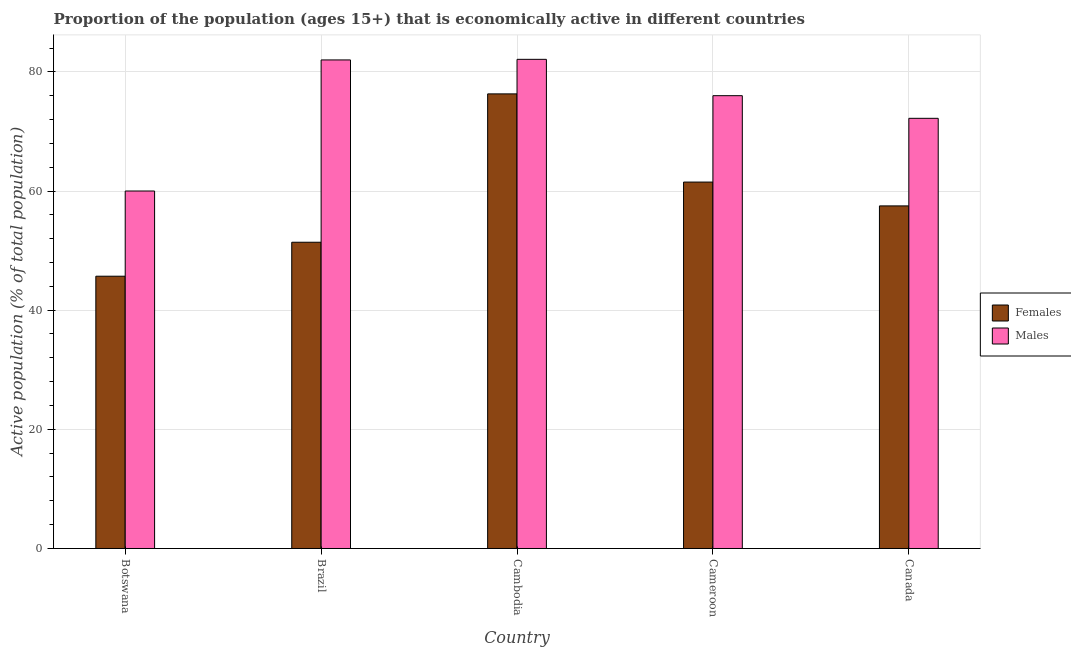How many groups of bars are there?
Give a very brief answer. 5. Are the number of bars per tick equal to the number of legend labels?
Your response must be concise. Yes. Are the number of bars on each tick of the X-axis equal?
Ensure brevity in your answer.  Yes. How many bars are there on the 4th tick from the left?
Provide a succinct answer. 2. How many bars are there on the 1st tick from the right?
Offer a very short reply. 2. What is the label of the 3rd group of bars from the left?
Your answer should be compact. Cambodia. What is the percentage of economically active female population in Cambodia?
Provide a short and direct response. 76.3. Across all countries, what is the maximum percentage of economically active male population?
Offer a very short reply. 82.1. Across all countries, what is the minimum percentage of economically active female population?
Offer a terse response. 45.7. In which country was the percentage of economically active female population maximum?
Provide a succinct answer. Cambodia. In which country was the percentage of economically active female population minimum?
Provide a short and direct response. Botswana. What is the total percentage of economically active female population in the graph?
Keep it short and to the point. 292.4. What is the difference between the percentage of economically active male population in Botswana and that in Canada?
Offer a terse response. -12.2. What is the difference between the percentage of economically active male population in Cambodia and the percentage of economically active female population in Brazil?
Provide a short and direct response. 30.7. What is the average percentage of economically active female population per country?
Offer a terse response. 58.48. What is the difference between the percentage of economically active male population and percentage of economically active female population in Brazil?
Keep it short and to the point. 30.6. In how many countries, is the percentage of economically active female population greater than 60 %?
Offer a terse response. 2. What is the ratio of the percentage of economically active male population in Brazil to that in Canada?
Provide a short and direct response. 1.14. What is the difference between the highest and the second highest percentage of economically active female population?
Your response must be concise. 14.8. What is the difference between the highest and the lowest percentage of economically active female population?
Provide a succinct answer. 30.6. In how many countries, is the percentage of economically active female population greater than the average percentage of economically active female population taken over all countries?
Make the answer very short. 2. Is the sum of the percentage of economically active male population in Botswana and Cambodia greater than the maximum percentage of economically active female population across all countries?
Give a very brief answer. Yes. What does the 2nd bar from the left in Brazil represents?
Your answer should be compact. Males. What does the 2nd bar from the right in Cambodia represents?
Your answer should be compact. Females. How many countries are there in the graph?
Offer a very short reply. 5. What is the difference between two consecutive major ticks on the Y-axis?
Offer a very short reply. 20. Does the graph contain grids?
Ensure brevity in your answer.  Yes. Where does the legend appear in the graph?
Keep it short and to the point. Center right. How many legend labels are there?
Offer a very short reply. 2. What is the title of the graph?
Offer a very short reply. Proportion of the population (ages 15+) that is economically active in different countries. Does "Time to export" appear as one of the legend labels in the graph?
Provide a short and direct response. No. What is the label or title of the X-axis?
Keep it short and to the point. Country. What is the label or title of the Y-axis?
Make the answer very short. Active population (% of total population). What is the Active population (% of total population) in Females in Botswana?
Ensure brevity in your answer.  45.7. What is the Active population (% of total population) of Females in Brazil?
Give a very brief answer. 51.4. What is the Active population (% of total population) of Males in Brazil?
Offer a terse response. 82. What is the Active population (% of total population) in Females in Cambodia?
Offer a terse response. 76.3. What is the Active population (% of total population) in Males in Cambodia?
Offer a very short reply. 82.1. What is the Active population (% of total population) of Females in Cameroon?
Ensure brevity in your answer.  61.5. What is the Active population (% of total population) in Females in Canada?
Offer a terse response. 57.5. What is the Active population (% of total population) of Males in Canada?
Give a very brief answer. 72.2. Across all countries, what is the maximum Active population (% of total population) of Females?
Keep it short and to the point. 76.3. Across all countries, what is the maximum Active population (% of total population) in Males?
Your response must be concise. 82.1. Across all countries, what is the minimum Active population (% of total population) of Females?
Provide a succinct answer. 45.7. Across all countries, what is the minimum Active population (% of total population) in Males?
Offer a very short reply. 60. What is the total Active population (% of total population) of Females in the graph?
Give a very brief answer. 292.4. What is the total Active population (% of total population) in Males in the graph?
Offer a terse response. 372.3. What is the difference between the Active population (% of total population) of Females in Botswana and that in Brazil?
Offer a very short reply. -5.7. What is the difference between the Active population (% of total population) of Females in Botswana and that in Cambodia?
Keep it short and to the point. -30.6. What is the difference between the Active population (% of total population) in Males in Botswana and that in Cambodia?
Provide a succinct answer. -22.1. What is the difference between the Active population (% of total population) of Females in Botswana and that in Cameroon?
Your response must be concise. -15.8. What is the difference between the Active population (% of total population) in Females in Brazil and that in Cambodia?
Make the answer very short. -24.9. What is the difference between the Active population (% of total population) in Males in Brazil and that in Cambodia?
Your response must be concise. -0.1. What is the difference between the Active population (% of total population) of Females in Brazil and that in Cameroon?
Your answer should be very brief. -10.1. What is the difference between the Active population (% of total population) of Males in Brazil and that in Cameroon?
Give a very brief answer. 6. What is the difference between the Active population (% of total population) of Males in Brazil and that in Canada?
Keep it short and to the point. 9.8. What is the difference between the Active population (% of total population) in Females in Cambodia and that in Canada?
Your answer should be compact. 18.8. What is the difference between the Active population (% of total population) of Males in Cameroon and that in Canada?
Your answer should be very brief. 3.8. What is the difference between the Active population (% of total population) in Females in Botswana and the Active population (% of total population) in Males in Brazil?
Your response must be concise. -36.3. What is the difference between the Active population (% of total population) of Females in Botswana and the Active population (% of total population) of Males in Cambodia?
Provide a succinct answer. -36.4. What is the difference between the Active population (% of total population) of Females in Botswana and the Active population (% of total population) of Males in Cameroon?
Ensure brevity in your answer.  -30.3. What is the difference between the Active population (% of total population) in Females in Botswana and the Active population (% of total population) in Males in Canada?
Offer a terse response. -26.5. What is the difference between the Active population (% of total population) of Females in Brazil and the Active population (% of total population) of Males in Cambodia?
Offer a terse response. -30.7. What is the difference between the Active population (% of total population) of Females in Brazil and the Active population (% of total population) of Males in Cameroon?
Your answer should be very brief. -24.6. What is the difference between the Active population (% of total population) in Females in Brazil and the Active population (% of total population) in Males in Canada?
Your response must be concise. -20.8. What is the difference between the Active population (% of total population) in Females in Cameroon and the Active population (% of total population) in Males in Canada?
Offer a very short reply. -10.7. What is the average Active population (% of total population) of Females per country?
Your answer should be compact. 58.48. What is the average Active population (% of total population) of Males per country?
Provide a short and direct response. 74.46. What is the difference between the Active population (% of total population) of Females and Active population (% of total population) of Males in Botswana?
Your answer should be very brief. -14.3. What is the difference between the Active population (% of total population) in Females and Active population (% of total population) in Males in Brazil?
Your answer should be compact. -30.6. What is the difference between the Active population (% of total population) of Females and Active population (% of total population) of Males in Canada?
Provide a succinct answer. -14.7. What is the ratio of the Active population (% of total population) of Females in Botswana to that in Brazil?
Your response must be concise. 0.89. What is the ratio of the Active population (% of total population) in Males in Botswana to that in Brazil?
Offer a very short reply. 0.73. What is the ratio of the Active population (% of total population) of Females in Botswana to that in Cambodia?
Your response must be concise. 0.6. What is the ratio of the Active population (% of total population) in Males in Botswana to that in Cambodia?
Offer a terse response. 0.73. What is the ratio of the Active population (% of total population) in Females in Botswana to that in Cameroon?
Keep it short and to the point. 0.74. What is the ratio of the Active population (% of total population) of Males in Botswana to that in Cameroon?
Offer a terse response. 0.79. What is the ratio of the Active population (% of total population) in Females in Botswana to that in Canada?
Your response must be concise. 0.79. What is the ratio of the Active population (% of total population) of Males in Botswana to that in Canada?
Provide a succinct answer. 0.83. What is the ratio of the Active population (% of total population) in Females in Brazil to that in Cambodia?
Keep it short and to the point. 0.67. What is the ratio of the Active population (% of total population) of Females in Brazil to that in Cameroon?
Your answer should be compact. 0.84. What is the ratio of the Active population (% of total population) in Males in Brazil to that in Cameroon?
Make the answer very short. 1.08. What is the ratio of the Active population (% of total population) in Females in Brazil to that in Canada?
Ensure brevity in your answer.  0.89. What is the ratio of the Active population (% of total population) in Males in Brazil to that in Canada?
Your answer should be very brief. 1.14. What is the ratio of the Active population (% of total population) of Females in Cambodia to that in Cameroon?
Ensure brevity in your answer.  1.24. What is the ratio of the Active population (% of total population) in Males in Cambodia to that in Cameroon?
Your answer should be compact. 1.08. What is the ratio of the Active population (% of total population) in Females in Cambodia to that in Canada?
Provide a short and direct response. 1.33. What is the ratio of the Active population (% of total population) in Males in Cambodia to that in Canada?
Your response must be concise. 1.14. What is the ratio of the Active population (% of total population) in Females in Cameroon to that in Canada?
Provide a succinct answer. 1.07. What is the ratio of the Active population (% of total population) of Males in Cameroon to that in Canada?
Your response must be concise. 1.05. What is the difference between the highest and the lowest Active population (% of total population) of Females?
Make the answer very short. 30.6. What is the difference between the highest and the lowest Active population (% of total population) of Males?
Offer a very short reply. 22.1. 